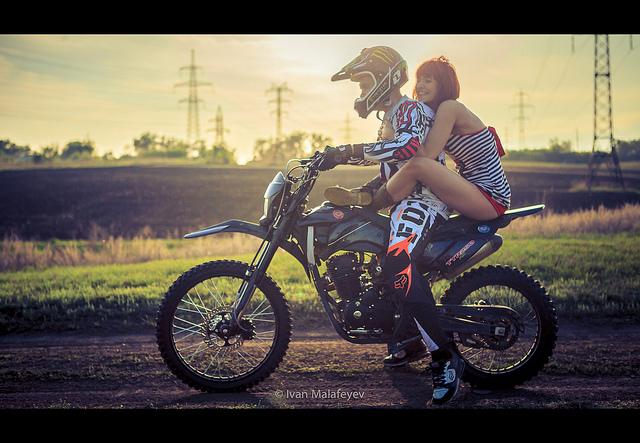Is this a difficult trick?
Keep it brief. No. Is the woman wearing a helmet?
Keep it brief. No. Are they racing against each other?
Be succinct. No. Do you see any power poles?
Keep it brief. Yes. Where are the people at?
Give a very brief answer. Country road. Does this woman appear happy?
Short answer required. Yes. What is under the rider's arm?
Give a very brief answer. Legs. 